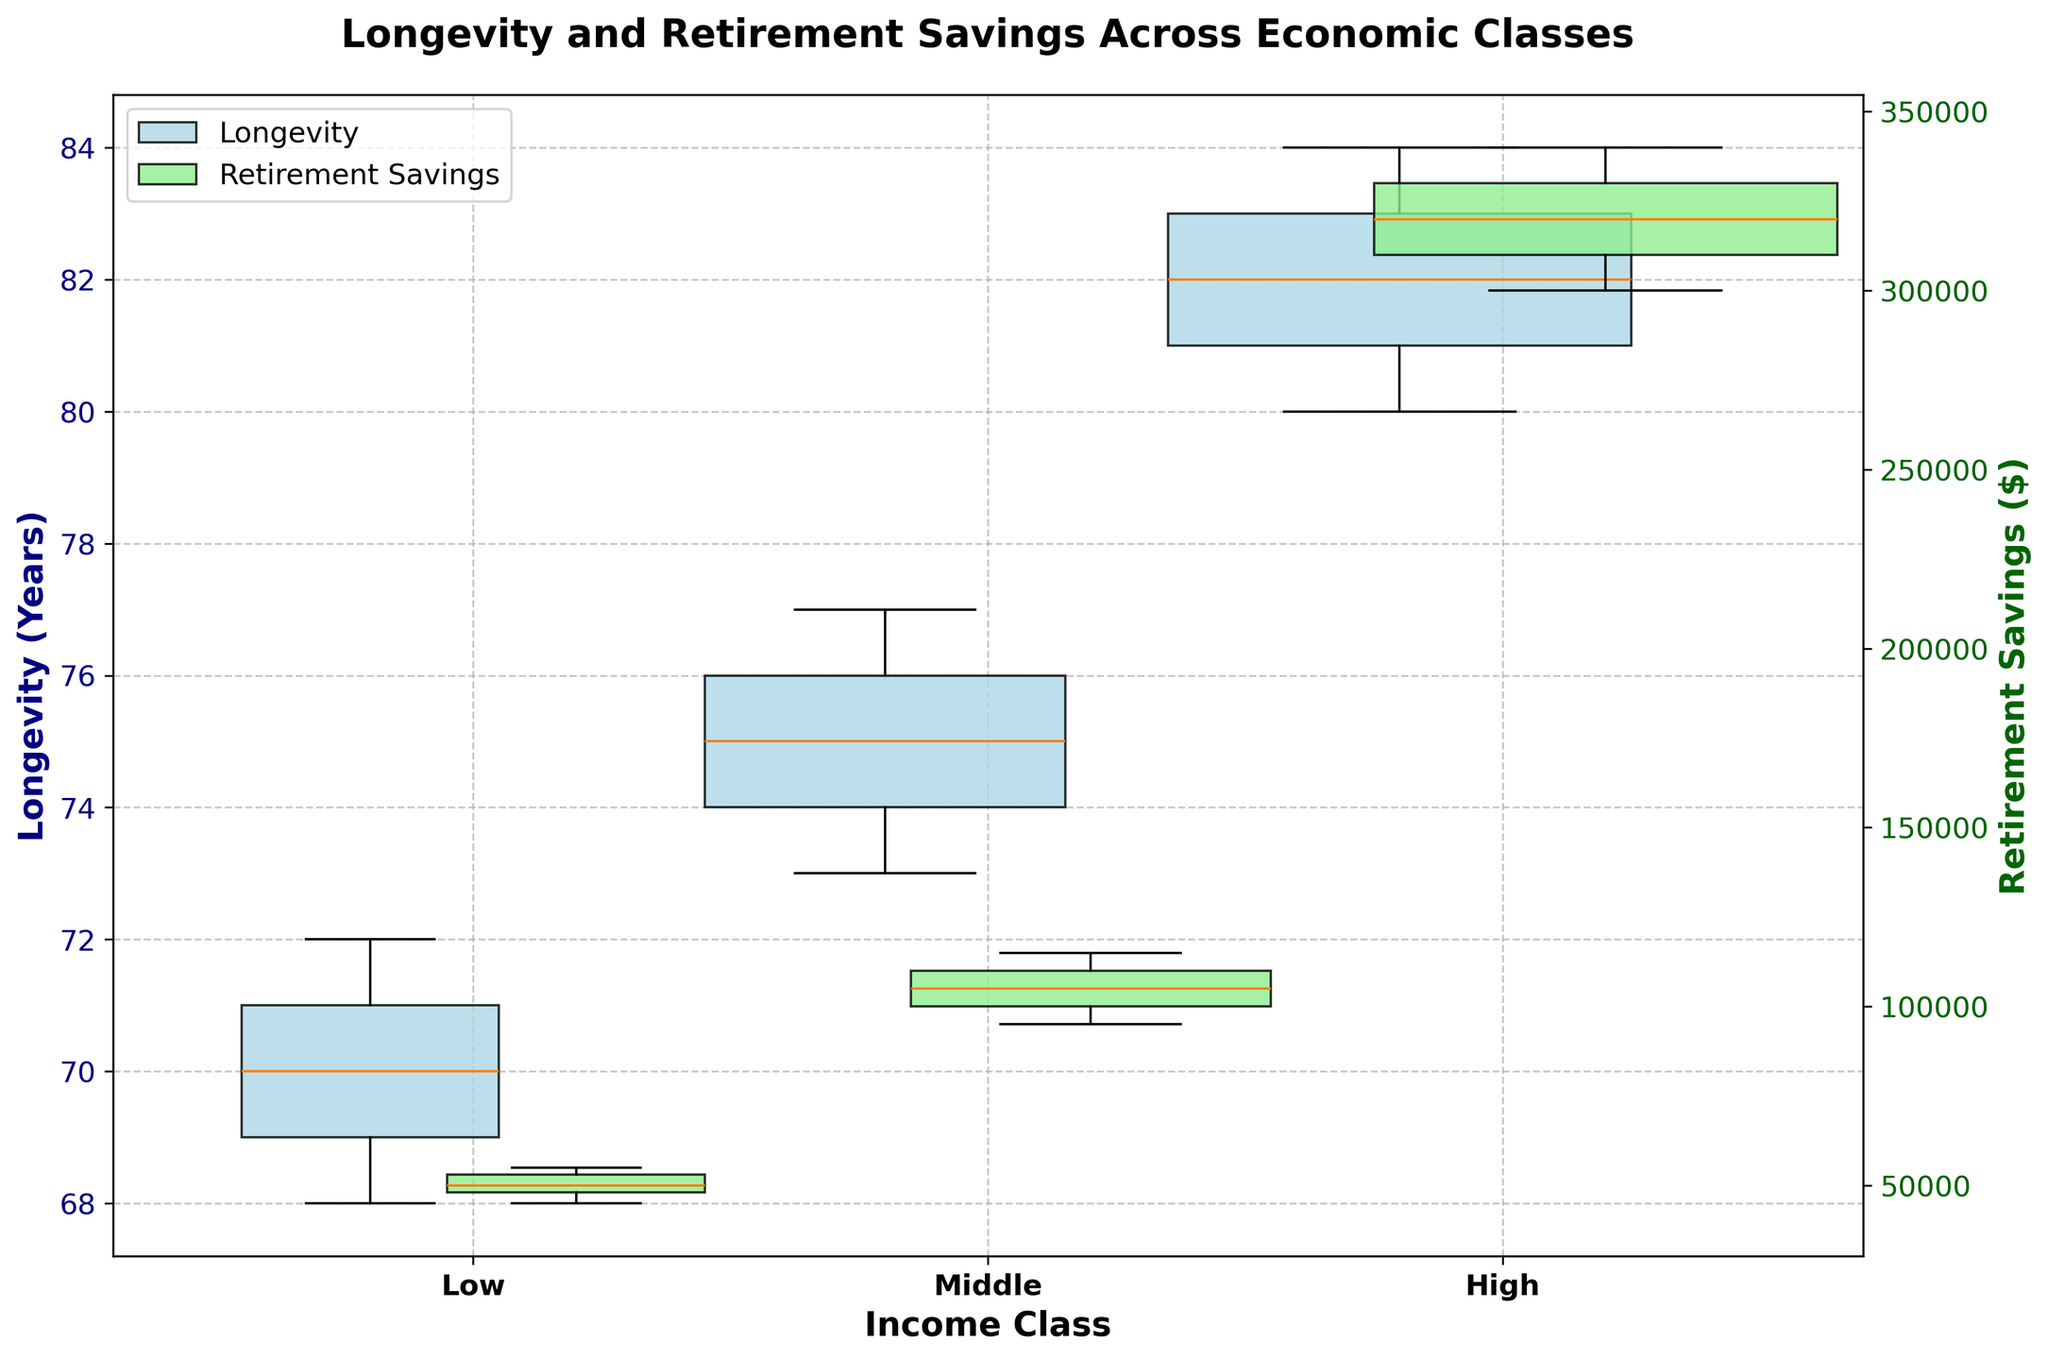What is the title of the plot? The title of the plot is located at the top center and describes the overall content. In this plot, it says "Longevity and Retirement Savings Across Economic Classes".
Answer: Longevity and Retirement Savings Across Economic Classes What colors represent longevity and retirement savings? The colors are indicated by the box colors in the legend. Longevity is represented by light blue, and retirement savings are represented by light green.
Answer: Light blue and Light green What income class has the widest box plot for retirement savings? The widths of the box plots for retirement savings are shown by the horizontal width of the green boxes. Among Low, Middle, and High classes, the High class has the widest box plot for savings.
Answer: High Which income class has the highest median longevity? The horizontal line inside the blue box represents the median value of longevity. For the High income class, this line is at the highest position compared to Middle and Low.
Answer: High How does the variability in retirement savings compare among the different income classes? The variability is indicated by the height of the green boxes. The High income class has the largest range (from top to bottom), followed by Middle and Low.
Answer: High > Middle > Low What is the median retirement savings for the Low income class? The median retirement savings is indicated by the horizontal line inside the green box for the Low income class, which appears around $50,000.
Answer: $50,000 Which income class has the smallest interquartile range (IQR) for longevity? The interquartile range (IQR) is measured by the height of the blue boxes. The Low income class has the smallest height, indicating the smallest IQR.
Answer: Low What is the approximate range of longevity for the Middle income class? The range can be determined by the distance from the bottom to the top of the box and the whiskers. For Middle income class, the lowest point is around 73 and the highest is around 77.
Answer: 73 to 77 Are the median values for retirement savings positively correlated with the income class? By looking at the median values (horizontal lines in green boxes) from Low to High: $50,000 at Low, around $100,000 at Middle, and above $300,000 at High, there is a clear positive trend.
Answer: Yes Which axis represents longevity and which represents retirement savings? The left vertical axis labeled "Longevity (Years)" is for longevity, and the right vertical axis labeled "Retirement Savings ($)" is for retirement savings.
Answer: Left: Longevity, Right: Retirement Savings 